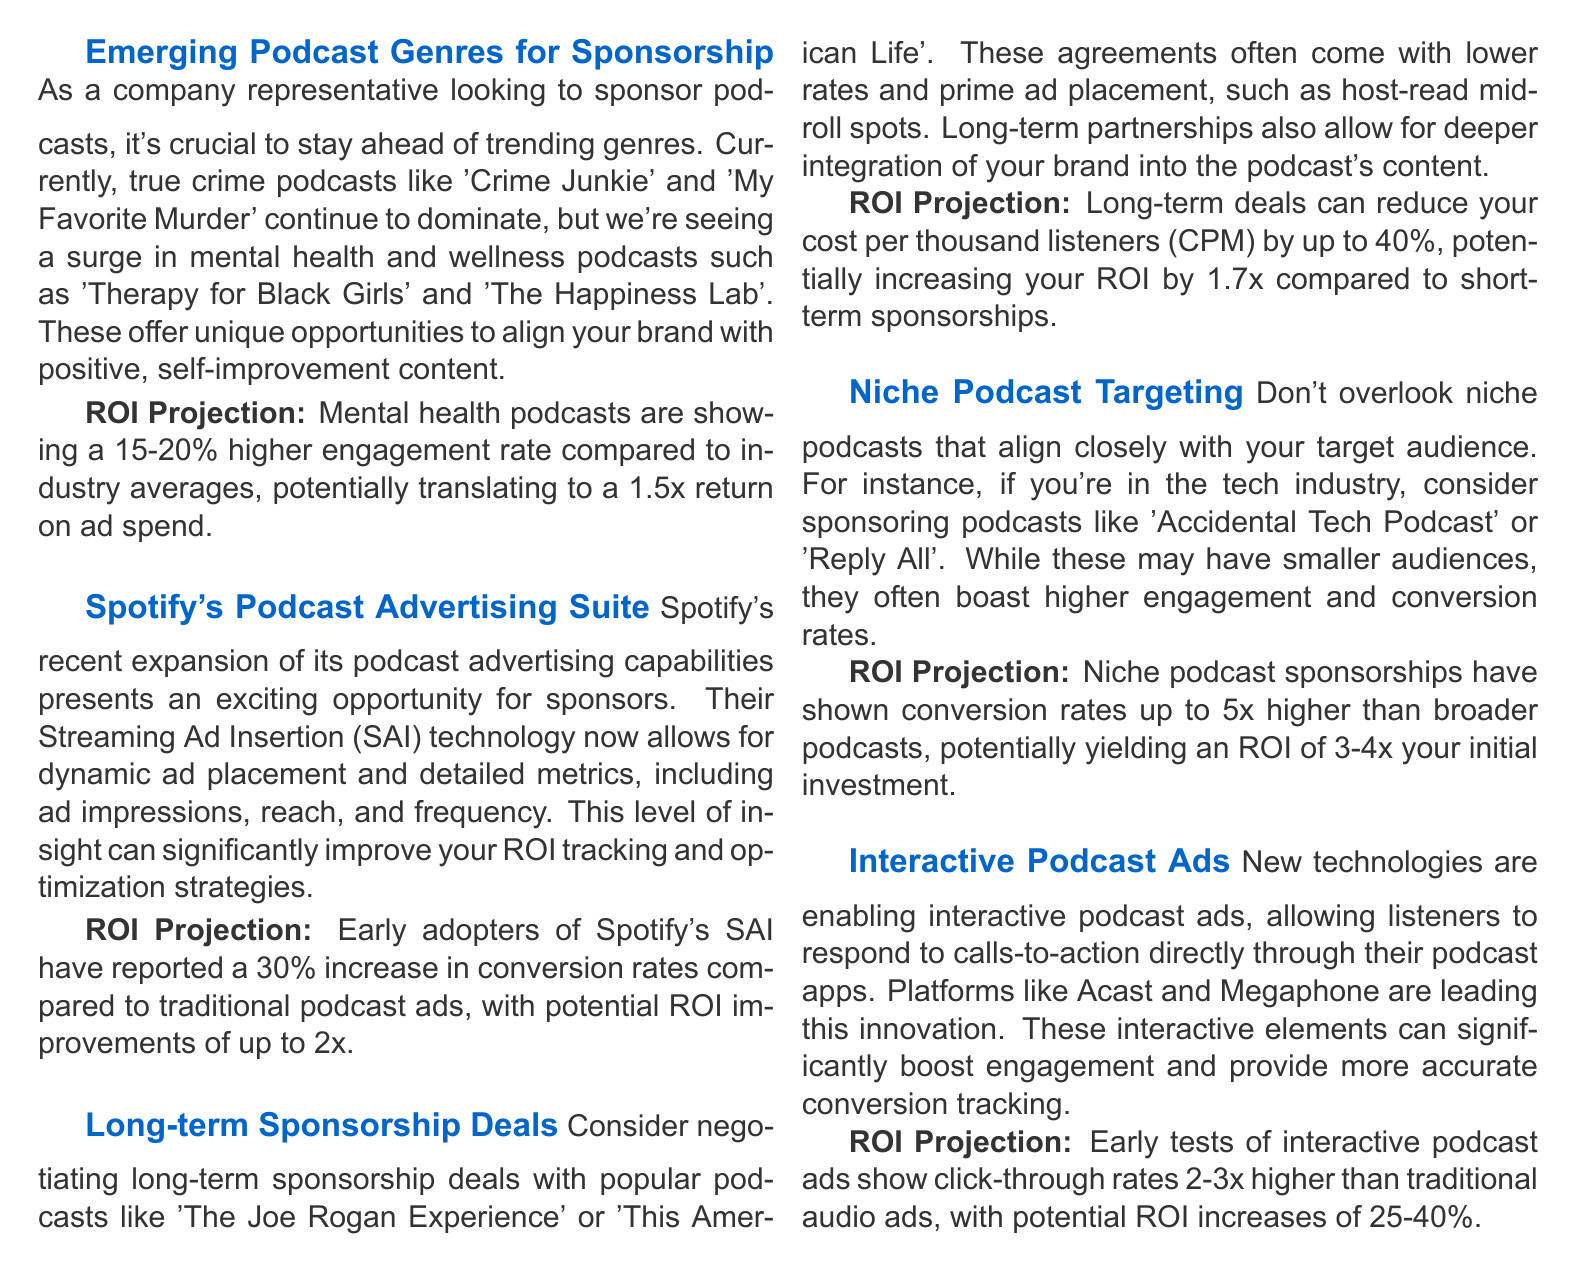What podcast genres are currently dominating? The text mentions true crime podcasts like 'Crime Junkie' and 'My Favorite Murder' as dominating, alongside a surge in mental health and wellness podcasts.
Answer: True crime podcasts What is the ROI projection for mental health podcasts? The document states that mental health podcasts show a 15-20% higher engagement rate, with a potential return on ad spend of 1.5x.
Answer: 1.5x What advertising technology has Spotify recently expanded? It mentions "Streaming Ad Insertion (SAI)" as the recently expanded technology that allows dynamic ad placement and detailed metrics.
Answer: Streaming Ad Insertion What potential increase in conversion rates have early adopters of Spotify's SAI reported? The document indicates a 30% increase in conversion rates compared to traditional podcast ads with the new technology.
Answer: 30% Which popular podcasts are suggested for long-term sponsorship deals? It recommends 'The Joe Rogan Experience' and 'This American Life' for long-term sponsorship deals.
Answer: The Joe Rogan Experience, This American Life What is the projected ROI for niche podcast sponsorships? The text states that niche podcast sponsorships can yield an ROI of 3-4x your initial investment.
Answer: 3-4x What advantages do interactive podcast ads provide? The document highlights that interactive podcast ads significantly boost engagement and provide more accurate conversion tracking.
Answer: Boost engagement What is the click-through rate improvement for interactive podcast ads compared to traditional audio ads? It mentions that early tests show click-through rates 2-3x higher than traditional audio ads.
Answer: 2-3x 